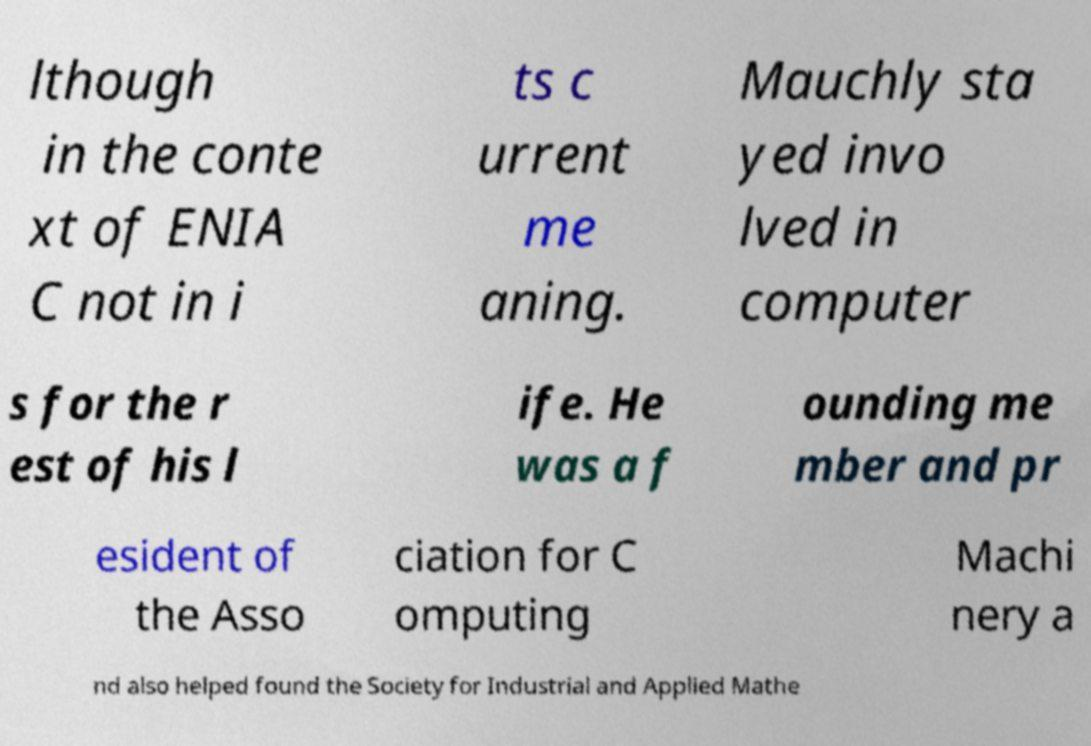Please read and relay the text visible in this image. What does it say? lthough in the conte xt of ENIA C not in i ts c urrent me aning. Mauchly sta yed invo lved in computer s for the r est of his l ife. He was a f ounding me mber and pr esident of the Asso ciation for C omputing Machi nery a nd also helped found the Society for Industrial and Applied Mathe 